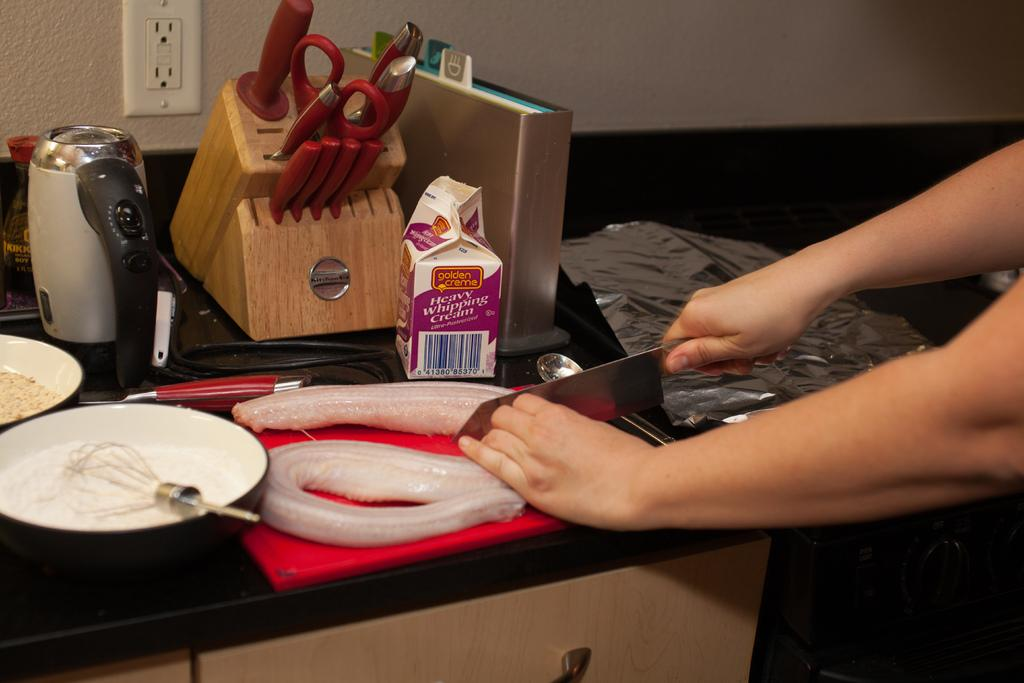<image>
Provide a brief description of the given image. someone chopping something behind a small carton that says 'heavy whipping cream' 